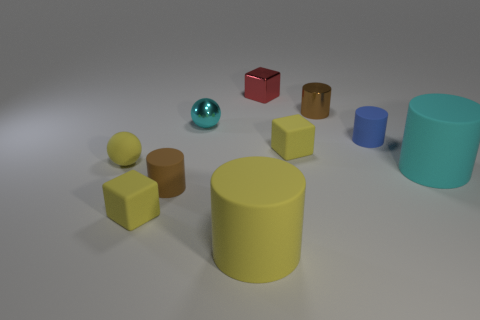There is a brown matte cylinder; are there any small metal cylinders left of it?
Your answer should be compact. No. Is the number of metallic blocks that are left of the tiny yellow sphere greater than the number of yellow cylinders?
Offer a very short reply. No. Are there any small things that have the same color as the small rubber sphere?
Your answer should be compact. Yes. What color is the other cylinder that is the same size as the yellow matte cylinder?
Your answer should be compact. Cyan. Are there any blocks that are on the left side of the yellow matte block in front of the small brown rubber object?
Provide a succinct answer. No. What is the material of the brown cylinder that is in front of the small cyan metallic object?
Your answer should be compact. Rubber. Does the brown object that is behind the tiny cyan metallic thing have the same material as the brown object in front of the big cyan rubber cylinder?
Your response must be concise. No. Are there the same number of cyan rubber cylinders in front of the big cyan thing and big yellow matte objects that are behind the small brown metal cylinder?
Provide a short and direct response. Yes. How many other large yellow cylinders are made of the same material as the big yellow cylinder?
Your answer should be very brief. 0. What is the shape of the tiny object that is the same color as the metallic cylinder?
Your answer should be very brief. Cylinder. 